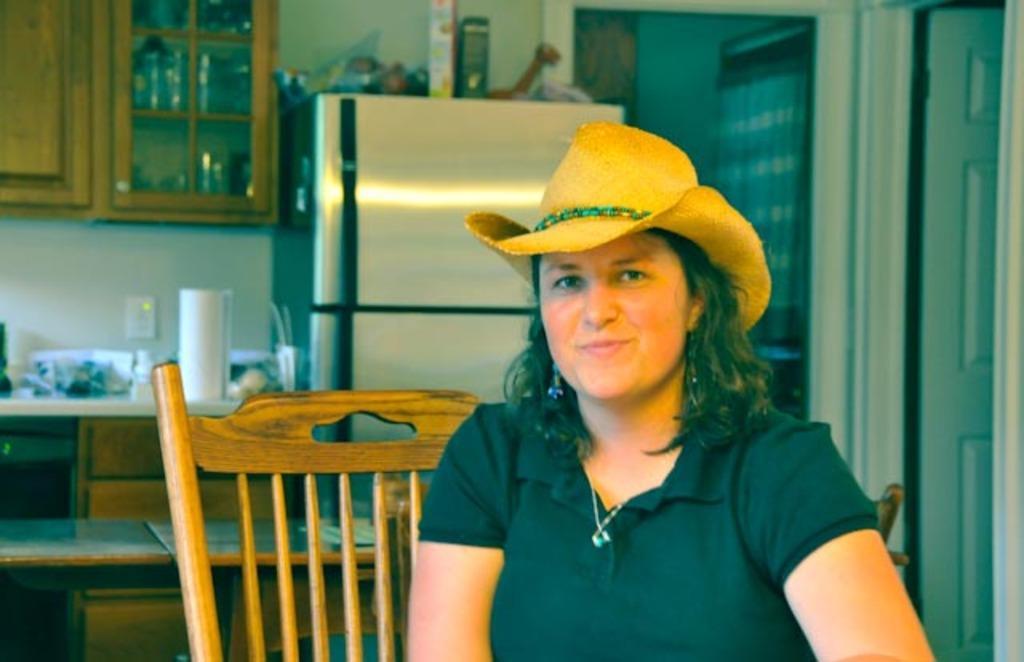Could you give a brief overview of what you see in this image? In this image I can see a woman wearing the hat and she is smiling. To the back of her there is a chair. In the back ground there is a refrigerator and there are some objects on it. To the left there is a cupboard. and some objects on the table. To the right there is a door. 